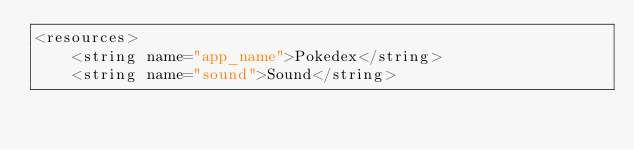<code> <loc_0><loc_0><loc_500><loc_500><_XML_><resources>
    <string name="app_name">Pokedex</string>
    <string name="sound">Sound</string></code> 